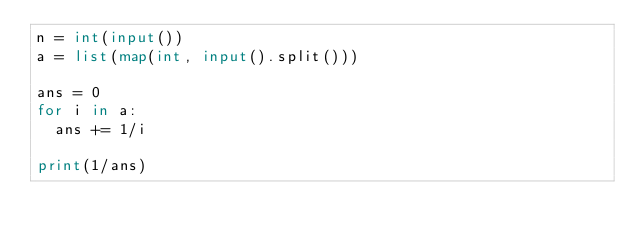Convert code to text. <code><loc_0><loc_0><loc_500><loc_500><_Python_>n = int(input())
a = list(map(int, input().split()))

ans = 0
for i in a:
  ans += 1/i
  
print(1/ans)</code> 